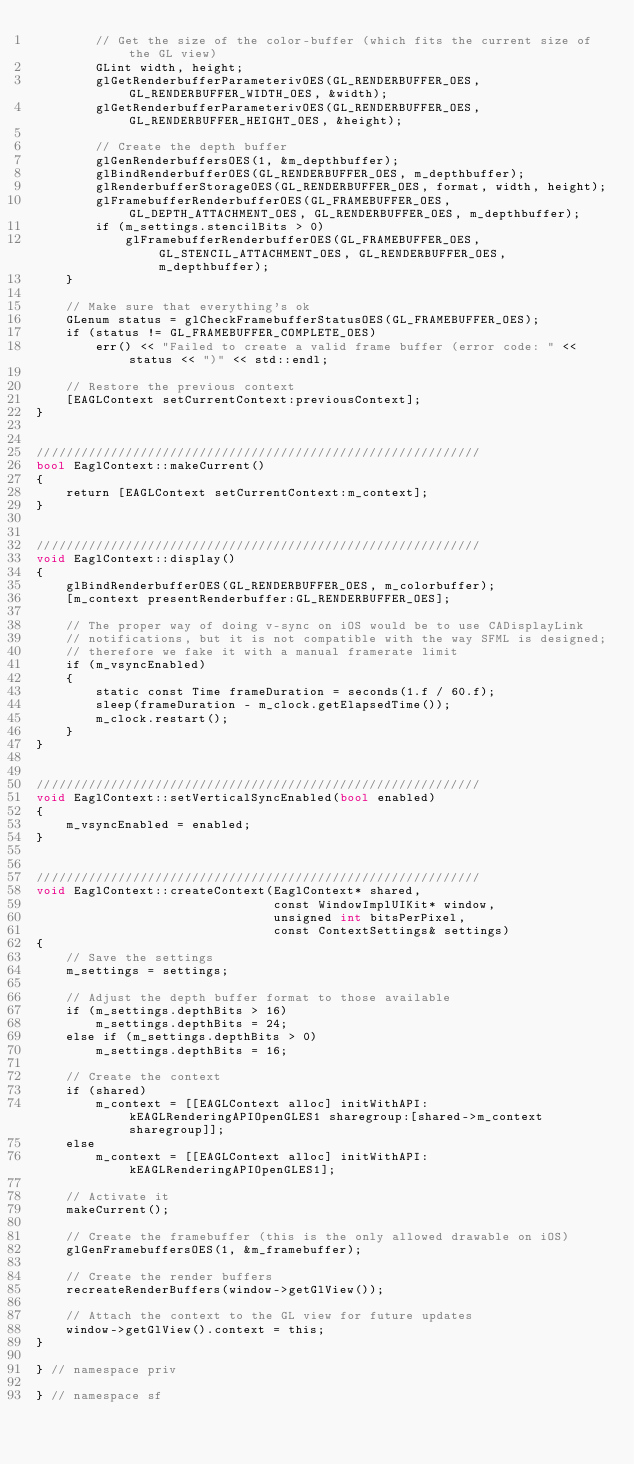Convert code to text. <code><loc_0><loc_0><loc_500><loc_500><_ObjectiveC_>        // Get the size of the color-buffer (which fits the current size of the GL view)
        GLint width, height;
        glGetRenderbufferParameterivOES(GL_RENDERBUFFER_OES, GL_RENDERBUFFER_WIDTH_OES, &width);
        glGetRenderbufferParameterivOES(GL_RENDERBUFFER_OES, GL_RENDERBUFFER_HEIGHT_OES, &height);

        // Create the depth buffer
        glGenRenderbuffersOES(1, &m_depthbuffer);
        glBindRenderbufferOES(GL_RENDERBUFFER_OES, m_depthbuffer);
        glRenderbufferStorageOES(GL_RENDERBUFFER_OES, format, width, height);
        glFramebufferRenderbufferOES(GL_FRAMEBUFFER_OES, GL_DEPTH_ATTACHMENT_OES, GL_RENDERBUFFER_OES, m_depthbuffer);
        if (m_settings.stencilBits > 0)
            glFramebufferRenderbufferOES(GL_FRAMEBUFFER_OES, GL_STENCIL_ATTACHMENT_OES, GL_RENDERBUFFER_OES, m_depthbuffer);
    }

    // Make sure that everything's ok
    GLenum status = glCheckFramebufferStatusOES(GL_FRAMEBUFFER_OES);
    if (status != GL_FRAMEBUFFER_COMPLETE_OES)
        err() << "Failed to create a valid frame buffer (error code: " << status << ")" << std::endl;

    // Restore the previous context
    [EAGLContext setCurrentContext:previousContext];
}


////////////////////////////////////////////////////////////
bool EaglContext::makeCurrent()
{
    return [EAGLContext setCurrentContext:m_context];
}


////////////////////////////////////////////////////////////
void EaglContext::display()
{
    glBindRenderbufferOES(GL_RENDERBUFFER_OES, m_colorbuffer);
    [m_context presentRenderbuffer:GL_RENDERBUFFER_OES];

    // The proper way of doing v-sync on iOS would be to use CADisplayLink
    // notifications, but it is not compatible with the way SFML is designed;
    // therefore we fake it with a manual framerate limit
    if (m_vsyncEnabled)
    {
        static const Time frameDuration = seconds(1.f / 60.f);
        sleep(frameDuration - m_clock.getElapsedTime());
        m_clock.restart();
    }
}


////////////////////////////////////////////////////////////
void EaglContext::setVerticalSyncEnabled(bool enabled)
{
    m_vsyncEnabled = enabled;
}


////////////////////////////////////////////////////////////
void EaglContext::createContext(EaglContext* shared,
                                const WindowImplUIKit* window,
                                unsigned int bitsPerPixel,
                                const ContextSettings& settings)
{
    // Save the settings
    m_settings = settings;

    // Adjust the depth buffer format to those available
    if (m_settings.depthBits > 16)
        m_settings.depthBits = 24;
    else if (m_settings.depthBits > 0)
        m_settings.depthBits = 16;

    // Create the context
    if (shared)
        m_context = [[EAGLContext alloc] initWithAPI:kEAGLRenderingAPIOpenGLES1 sharegroup:[shared->m_context sharegroup]];
    else
        m_context = [[EAGLContext alloc] initWithAPI:kEAGLRenderingAPIOpenGLES1];

    // Activate it
    makeCurrent();

    // Create the framebuffer (this is the only allowed drawable on iOS)
    glGenFramebuffersOES(1, &m_framebuffer);

    // Create the render buffers
    recreateRenderBuffers(window->getGlView());

    // Attach the context to the GL view for future updates
    window->getGlView().context = this;
}

} // namespace priv

} // namespace sf

</code> 